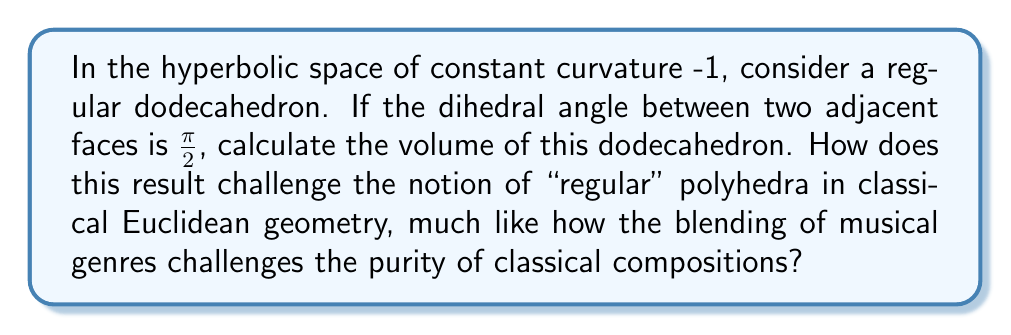Could you help me with this problem? Let's approach this step-by-step:

1) In hyperbolic space, the volume of a regular dodecahedron is given by the Schläfli formula:

   $$V = \frac{-5\pi}{3} + 10\alpha - 30\theta$$

   where $\alpha$ is the dihedral angle and $\theta$ is the solid angle at each vertex.

2) We're given that $\alpha = \frac{\pi}{2}$. We need to find $\theta$.

3) In a hyperbolic dodecahedron with right dihedral angles, three faces meet at each vertex. The angle between any two face edges at a vertex is $\frac{\pi}{3}$. This forms a right-angled pentagon in the unit sphere around each vertex.

4) The area of this spherical pentagon gives us the solid angle $\theta$. It can be calculated using:

   $$\theta = 3\cdot\frac{\pi}{2} - 5\cdot\frac{\pi}{3} = \frac{\pi}{2}$$

5) Now we can substitute these values into our volume formula:

   $$V = \frac{-5\pi}{3} + 10\cdot\frac{\pi}{2} - 30\cdot\frac{\pi}{2}$$

6) Simplifying:
   
   $$V = \frac{-5\pi}{3} + 5\pi - 15\pi = -\frac{25\pi}{3}$$

7) This negative volume is a peculiarity of hyperbolic geometry. It challenges our Euclidean intuition, much like how genre-blending in music challenges classical purists. In hyperbolic space, as objects grow larger, their volume can become arbitrarily negative.
Answer: $-\frac{25\pi}{3}$ 